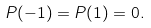<formula> <loc_0><loc_0><loc_500><loc_500>P ( - 1 ) = P ( 1 ) = 0 .</formula> 